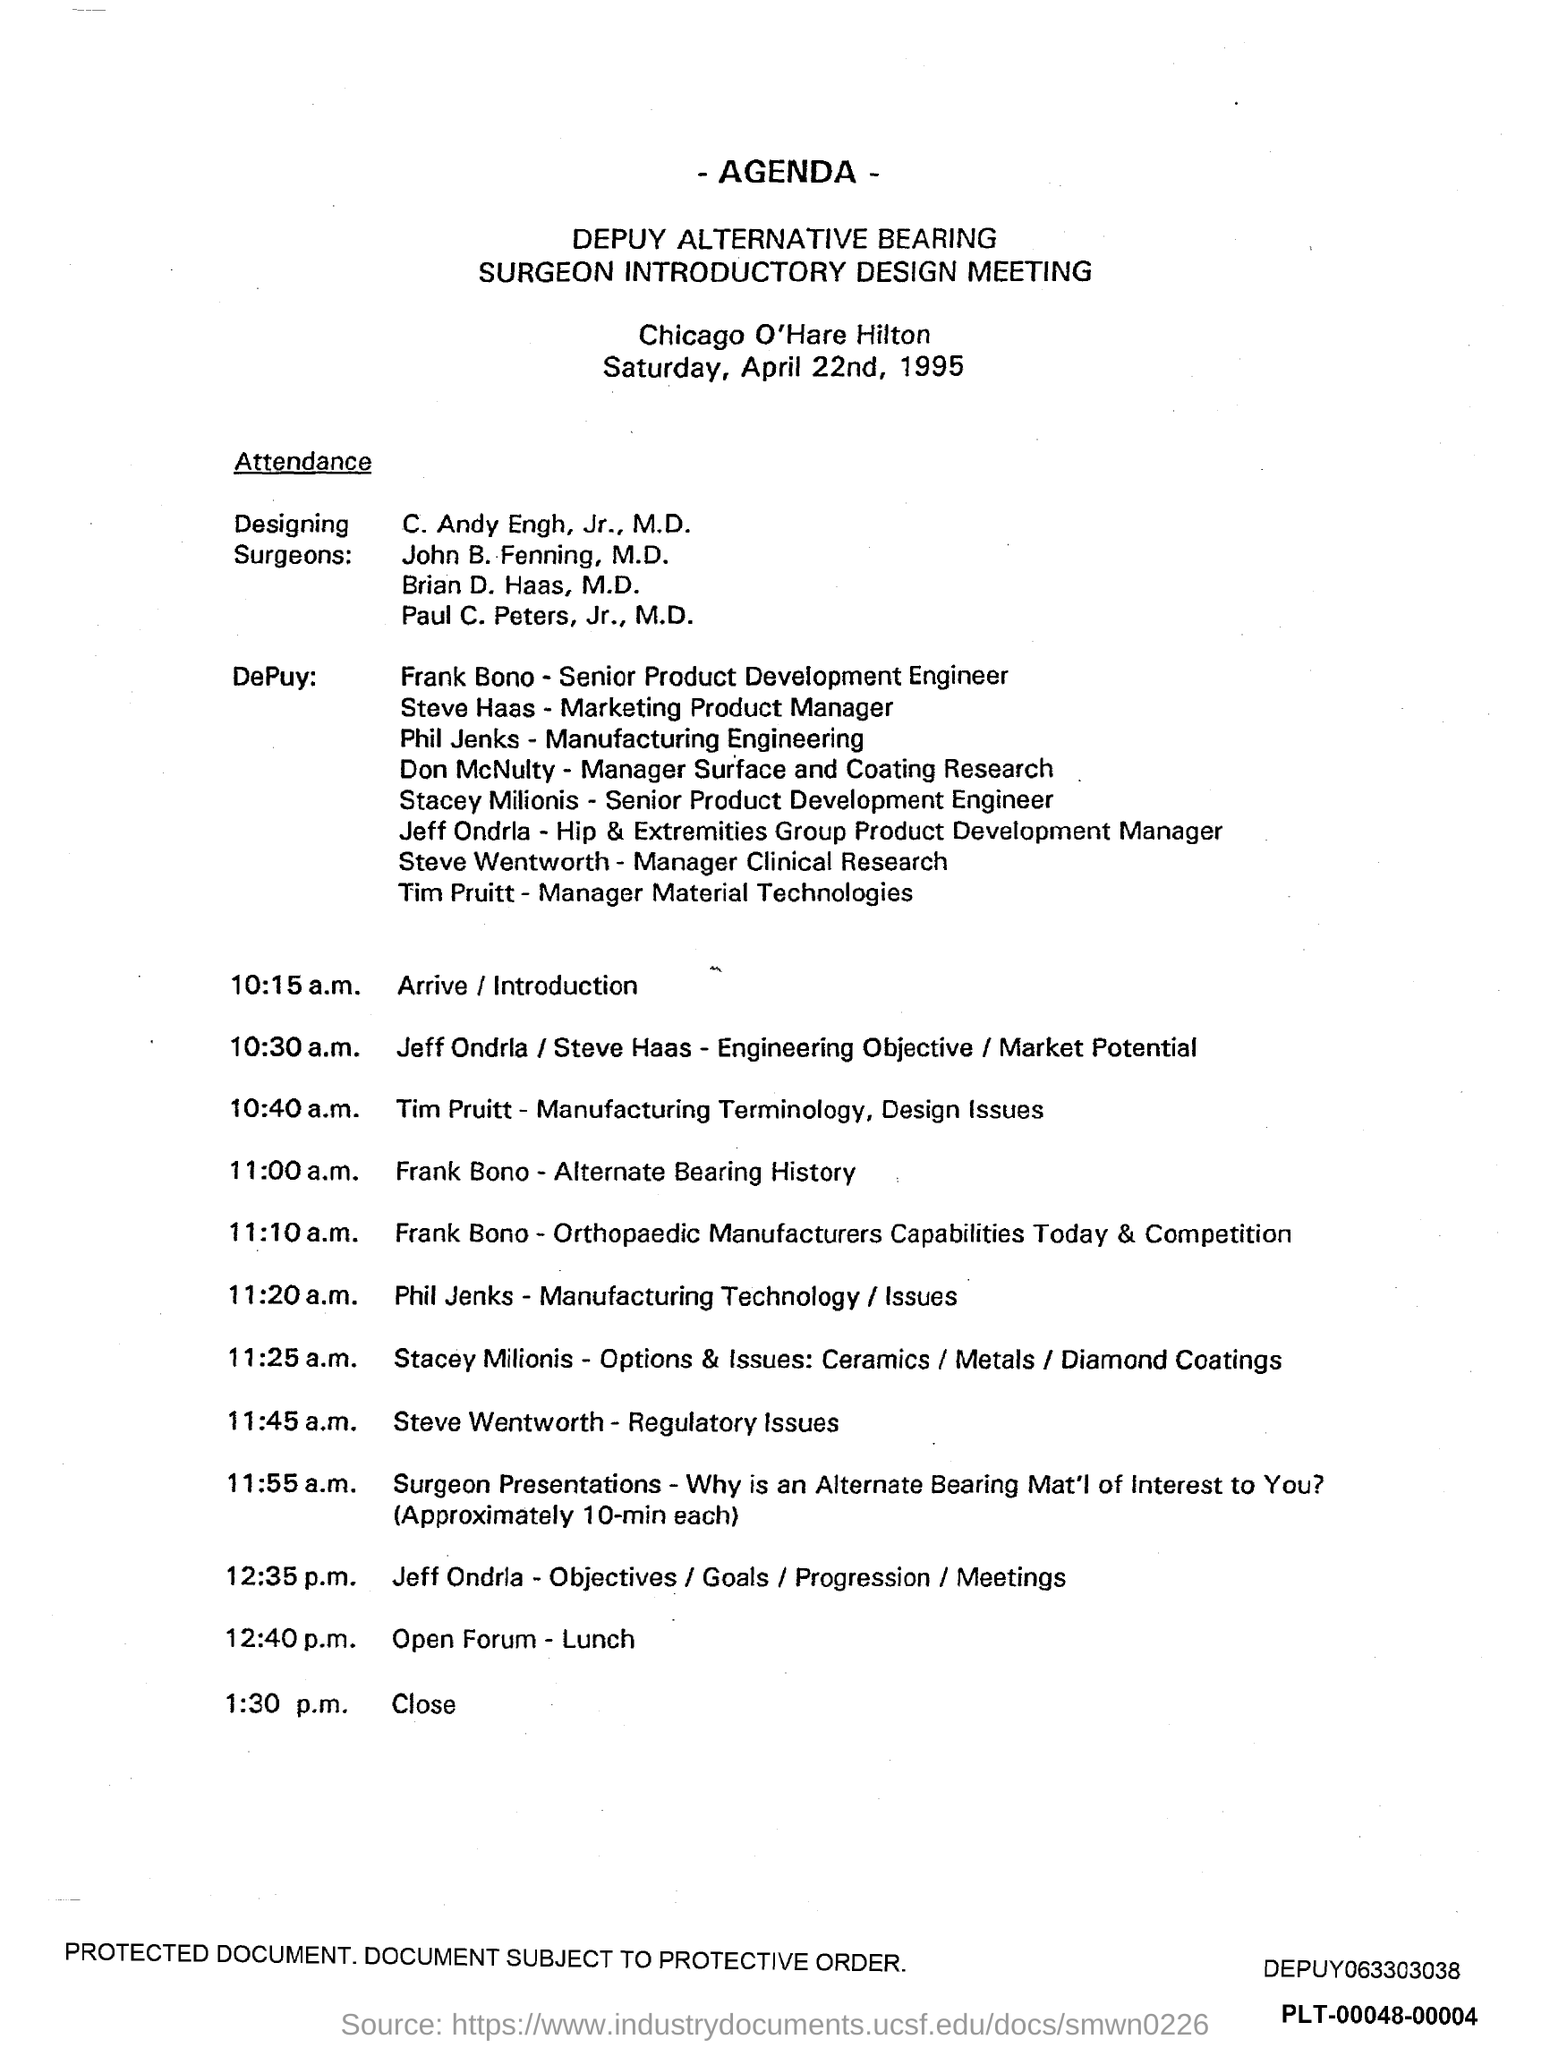Could you provide more information about the main topics discussed at this meeting? Certainly! The meeting covered a range of topics related to alternate bearing surfaces in orthopaedics. Key discussions included Engineering Objective/Market Potential, Manufacturing Terminology, Alternate Bearing History, Capabilities of Orthopaedic Manufacturers today, Manufacturing Technology Issues, Options for Ceramics/Metals/Diamond Coatings, and Regulatory Issues. These topics are crucial for the development and understanding of alternate bearing materials in surgical implants. 